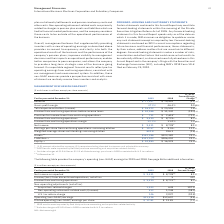According to International Business Machines's financial document, How has the revenue year to year change been adjusted? (1.0) percent adjusted for currency; 0.2 percent excluding divested businesses and adjusted for currency. The document states: "* (1.0) percent adjusted for currency; 0.2 percent excluding divested businesses and adjusted for currency. ** 2019 results were impacted by Red Hat p..." Also, What impacted the 2019 results? 2019 results were impacted by Red Hat purchase accounting and acquisition-related activity. The document states: "divested businesses and adjusted for currency. ** 2019 results were impacted by Red Hat purchase accounting and acquisition-related activity. + Includ..." Also, What charges were included in 2018? Includes charges of $2.0 billion or $2.23 of diluted earnings per share in 2018 associated with U.S. tax reform.. The document states: "ase accounting and acquisition-related activity. + Includes charges of $2.0 billion or $2.23 of diluted earnings per share in 2018 associated with U.S..." Also, can you calculate: What was the increase / (decrease) in revenue from 2018 to 2019? Based on the calculation: 77,147 - 79,591, the result is -2444 (in millions). This is based on the information: "Revenue $ 77,147 $ 79,591 (3.1)%* Revenue $ 77,147 $ 79,591 (3.1)%*..." The key data points involved are: 77,147, 79,591. Also, can you calculate: What was the total assets turnover ratio in 2019? Based on the calculation: 77,147 / 152,186, the result is 50.69 (percentage). This is based on the information: "Revenue $ 77,147 $ 79,591 (3.1)%* Assets ++ $152,186 $123,382 23.3%..." The key data points involved are: 152,186, 77,147. Also, can you calculate: What was the percentage increase / (decrease) in the net income from 2018 to 2019? To answer this question, I need to perform calculations using the financial data. The calculation is: 9,431 / 8,728 - 1, which equals 8.05 (percentage). This is based on the information: "Net income $ 9,431 $ 8,728 + 8.1% Net income $ 9,431 $ 8,728 + 8.1%..." The key data points involved are: 8,728, 9,431. 